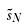Convert formula to latex. <formula><loc_0><loc_0><loc_500><loc_500>\tilde { s } _ { N }</formula> 